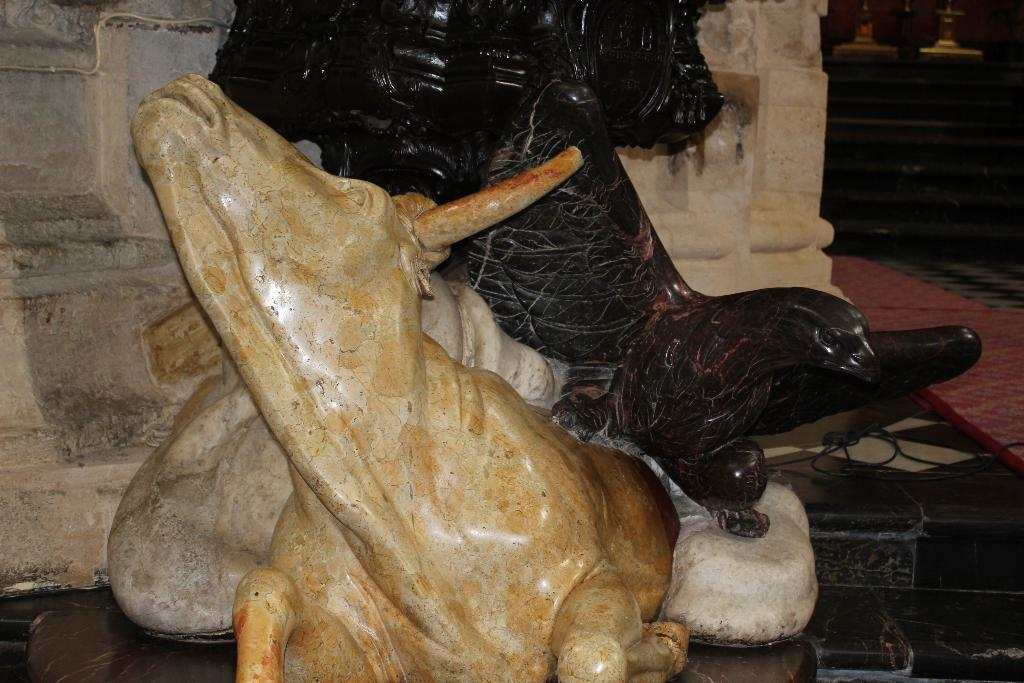What type of objects are on the floor in the image? There are statues of animals on the floor. What can be seen in the background of the image? There is a wall and a carpet in the background of the image. Are there any other objects visible on the floor in the background? Yes, there is a cable on the floor in the background of the image. What else can be seen in the background of the image? There are other objects visible in the background of the image. What sound does the bell make when the animal sneezes in the image? There is no bell or animal sneezing present in the image. 